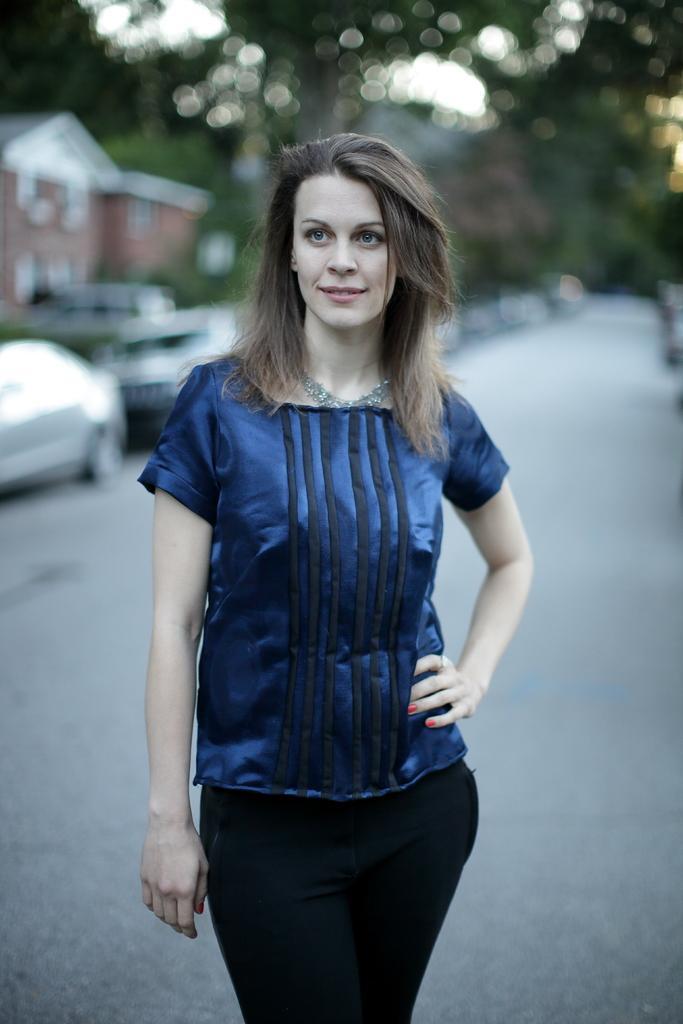Describe this image in one or two sentences. Here we can see a woman standing on the road. In the background there are trees,vehicles,buildings and sky. 